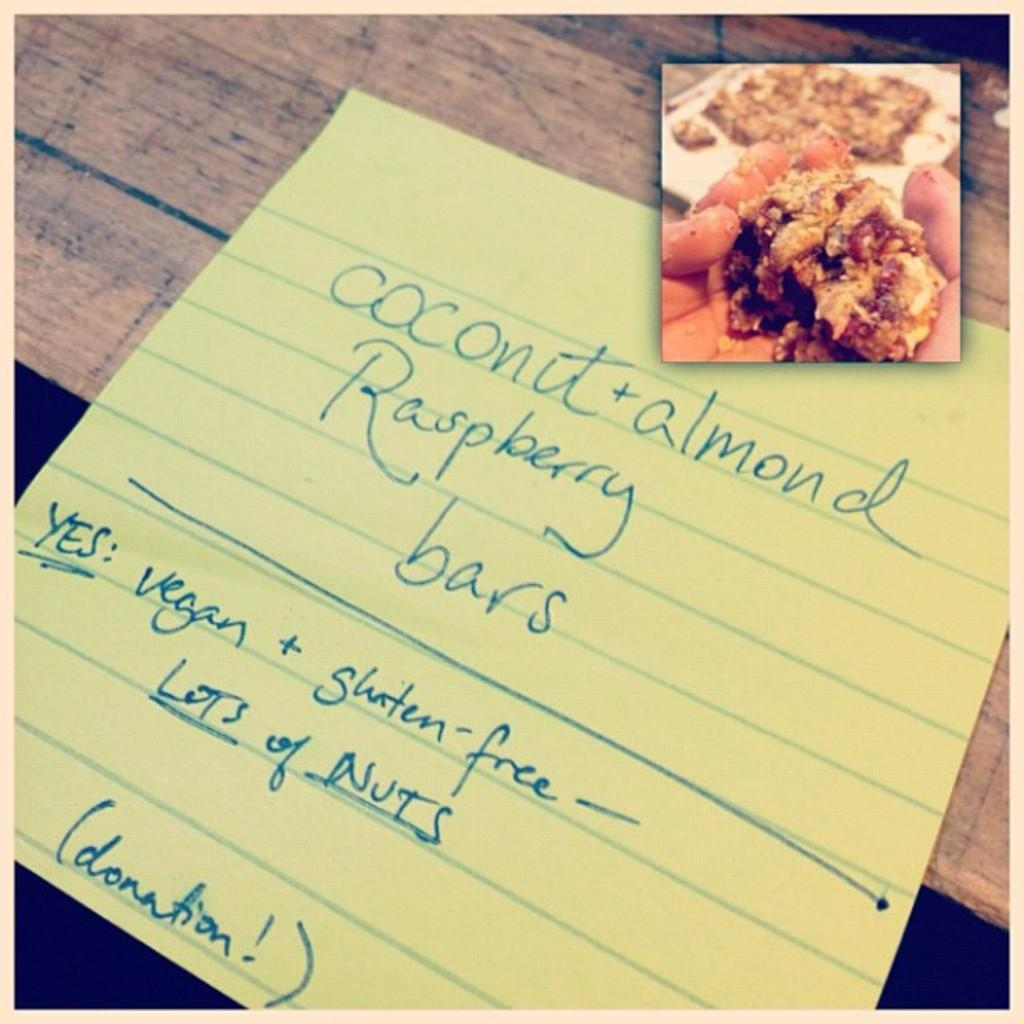Provide a one-sentence caption for the provided image. The yellow paper has Coconut written on it. 